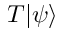Convert formula to latex. <formula><loc_0><loc_0><loc_500><loc_500>T | \psi \rangle</formula> 